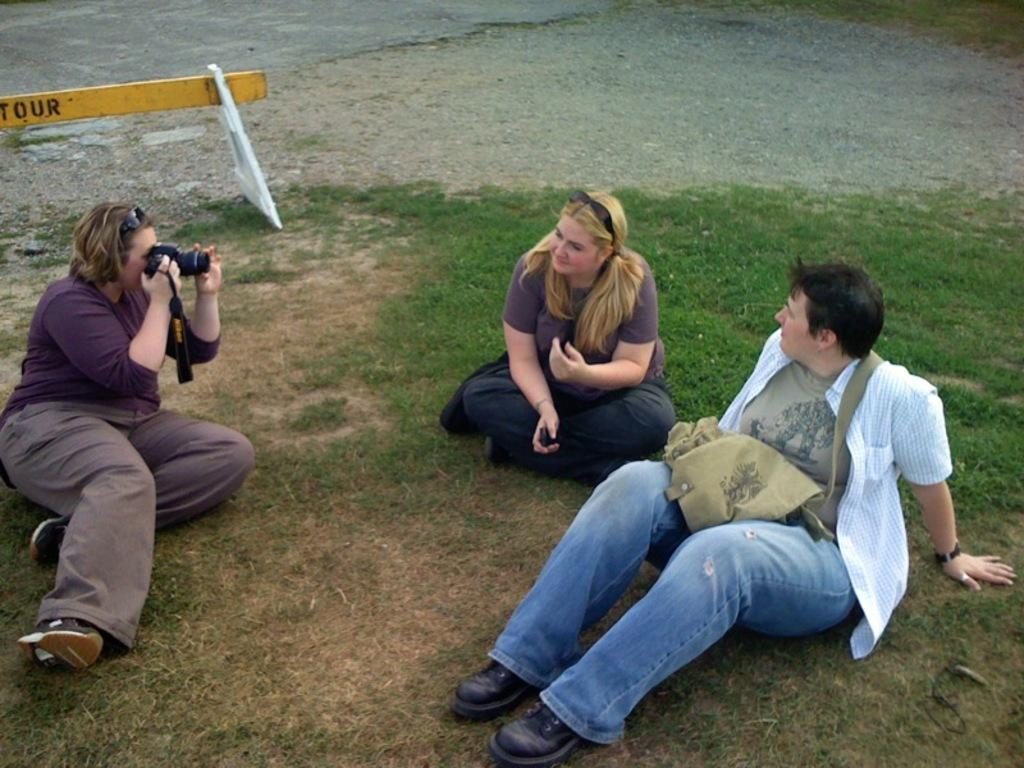How many people are sitting in the image? There are three people sitting in the image. What is the person on the left doing? The person on the left is holding a camera. What can be seen in the background of the image? There is a road and a stand in the background. What type of connection is being made between the people in the image? There is no indication of a connection being made between the people in the image. What idea is being discussed by the people in the image? There is no information about any discussion or idea being shared among the people in the image. 